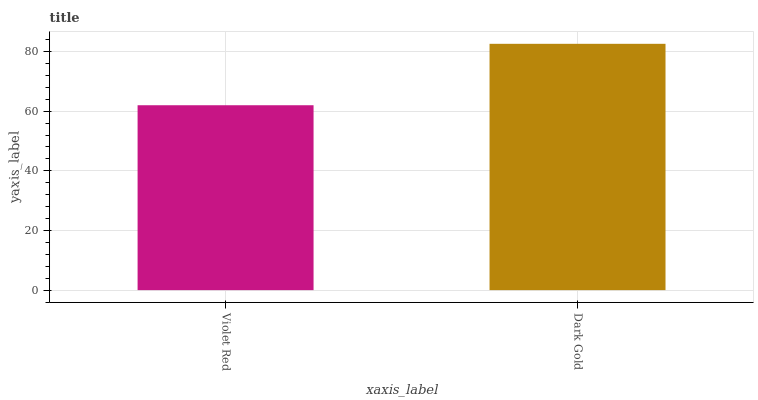Is Violet Red the minimum?
Answer yes or no. Yes. Is Dark Gold the maximum?
Answer yes or no. Yes. Is Dark Gold the minimum?
Answer yes or no. No. Is Dark Gold greater than Violet Red?
Answer yes or no. Yes. Is Violet Red less than Dark Gold?
Answer yes or no. Yes. Is Violet Red greater than Dark Gold?
Answer yes or no. No. Is Dark Gold less than Violet Red?
Answer yes or no. No. Is Dark Gold the high median?
Answer yes or no. Yes. Is Violet Red the low median?
Answer yes or no. Yes. Is Violet Red the high median?
Answer yes or no. No. Is Dark Gold the low median?
Answer yes or no. No. 